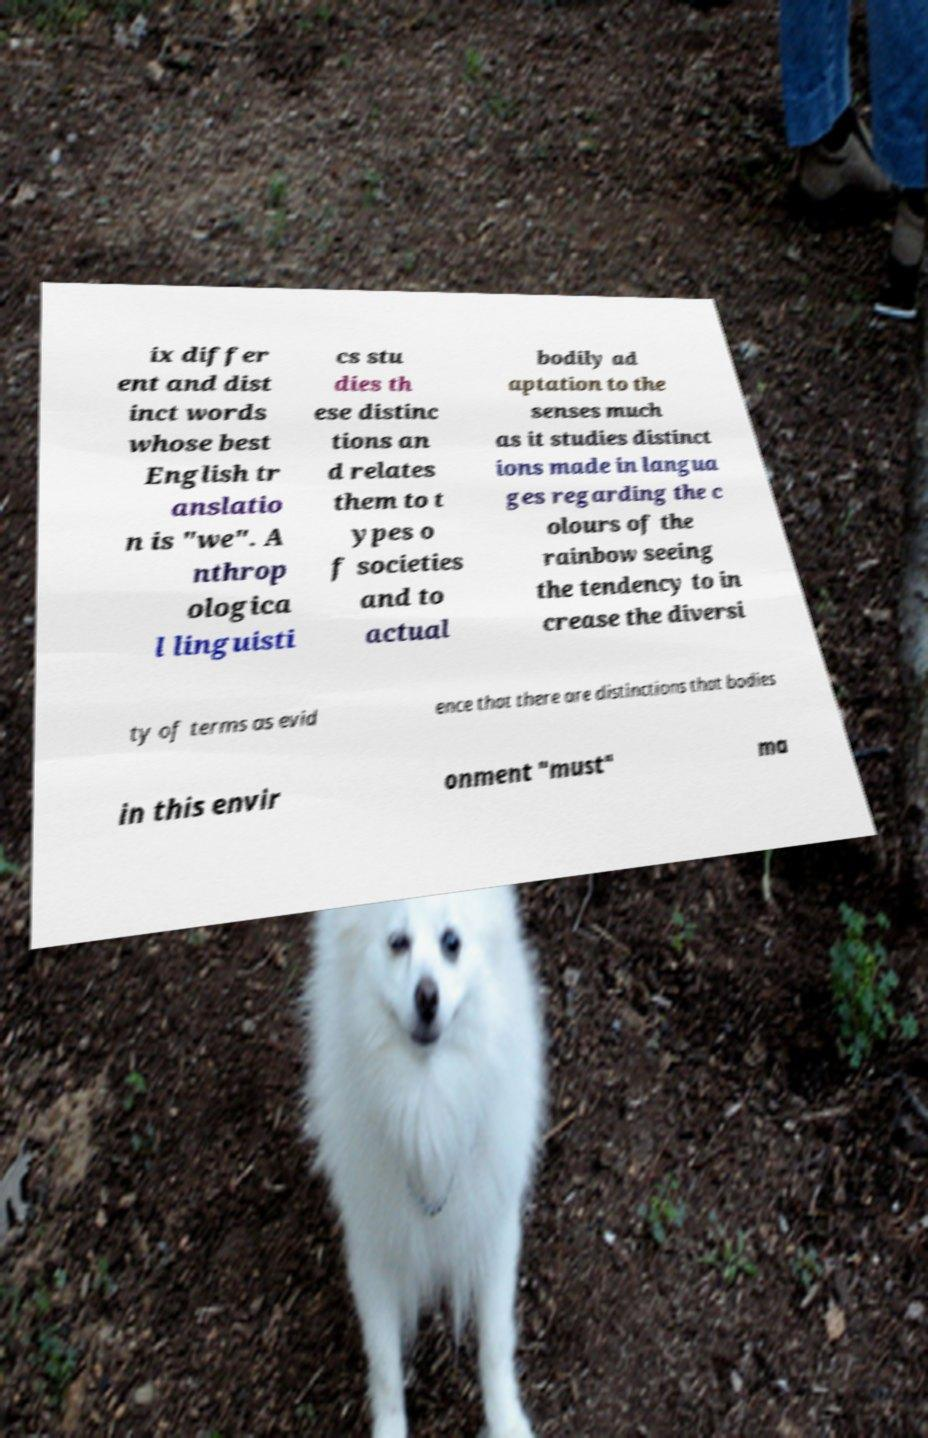There's text embedded in this image that I need extracted. Can you transcribe it verbatim? ix differ ent and dist inct words whose best English tr anslatio n is "we". A nthrop ologica l linguisti cs stu dies th ese distinc tions an d relates them to t ypes o f societies and to actual bodily ad aptation to the senses much as it studies distinct ions made in langua ges regarding the c olours of the rainbow seeing the tendency to in crease the diversi ty of terms as evid ence that there are distinctions that bodies in this envir onment "must" ma 